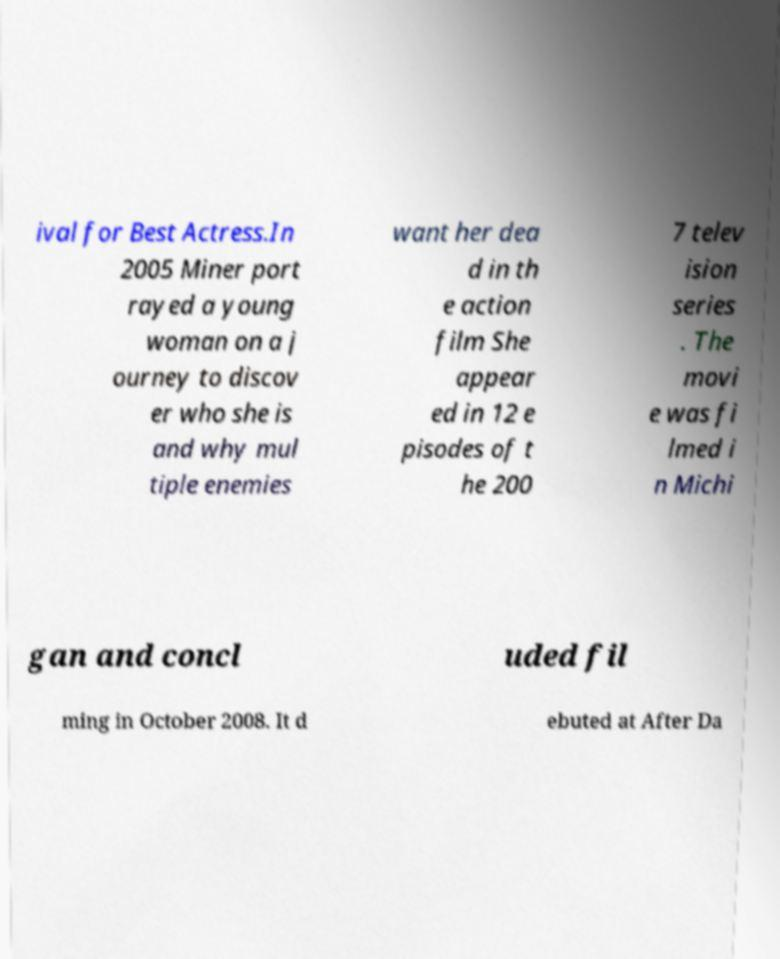Could you extract and type out the text from this image? ival for Best Actress.In 2005 Miner port rayed a young woman on a j ourney to discov er who she is and why mul tiple enemies want her dea d in th e action film She appear ed in 12 e pisodes of t he 200 7 telev ision series . The movi e was fi lmed i n Michi gan and concl uded fil ming in October 2008. It d ebuted at After Da 